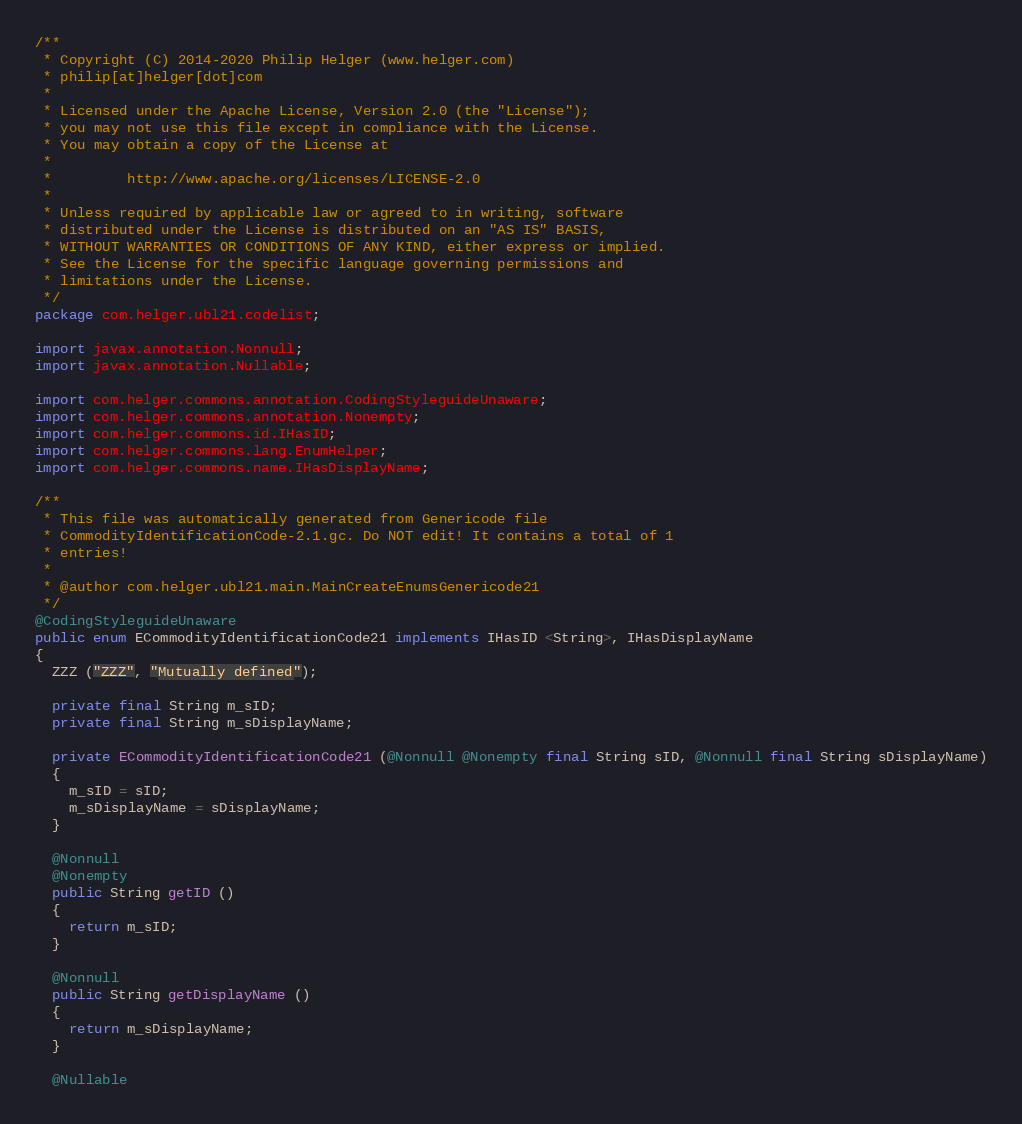<code> <loc_0><loc_0><loc_500><loc_500><_Java_>/**
 * Copyright (C) 2014-2020 Philip Helger (www.helger.com)
 * philip[at]helger[dot]com
 *
 * Licensed under the Apache License, Version 2.0 (the "License");
 * you may not use this file except in compliance with the License.
 * You may obtain a copy of the License at
 *
 *         http://www.apache.org/licenses/LICENSE-2.0
 *
 * Unless required by applicable law or agreed to in writing, software
 * distributed under the License is distributed on an "AS IS" BASIS,
 * WITHOUT WARRANTIES OR CONDITIONS OF ANY KIND, either express or implied.
 * See the License for the specific language governing permissions and
 * limitations under the License.
 */
package com.helger.ubl21.codelist;

import javax.annotation.Nonnull;
import javax.annotation.Nullable;

import com.helger.commons.annotation.CodingStyleguideUnaware;
import com.helger.commons.annotation.Nonempty;
import com.helger.commons.id.IHasID;
import com.helger.commons.lang.EnumHelper;
import com.helger.commons.name.IHasDisplayName;

/**
 * This file was automatically generated from Genericode file
 * CommodityIdentificationCode-2.1.gc. Do NOT edit! It contains a total of 1
 * entries!
 * 
 * @author com.helger.ubl21.main.MainCreateEnumsGenericode21
 */
@CodingStyleguideUnaware
public enum ECommodityIdentificationCode21 implements IHasID <String>, IHasDisplayName
{
  ZZZ ("ZZZ", "Mutually defined");

  private final String m_sID;
  private final String m_sDisplayName;

  private ECommodityIdentificationCode21 (@Nonnull @Nonempty final String sID, @Nonnull final String sDisplayName)
  {
    m_sID = sID;
    m_sDisplayName = sDisplayName;
  }

  @Nonnull
  @Nonempty
  public String getID ()
  {
    return m_sID;
  }

  @Nonnull
  public String getDisplayName ()
  {
    return m_sDisplayName;
  }

  @Nullable</code> 